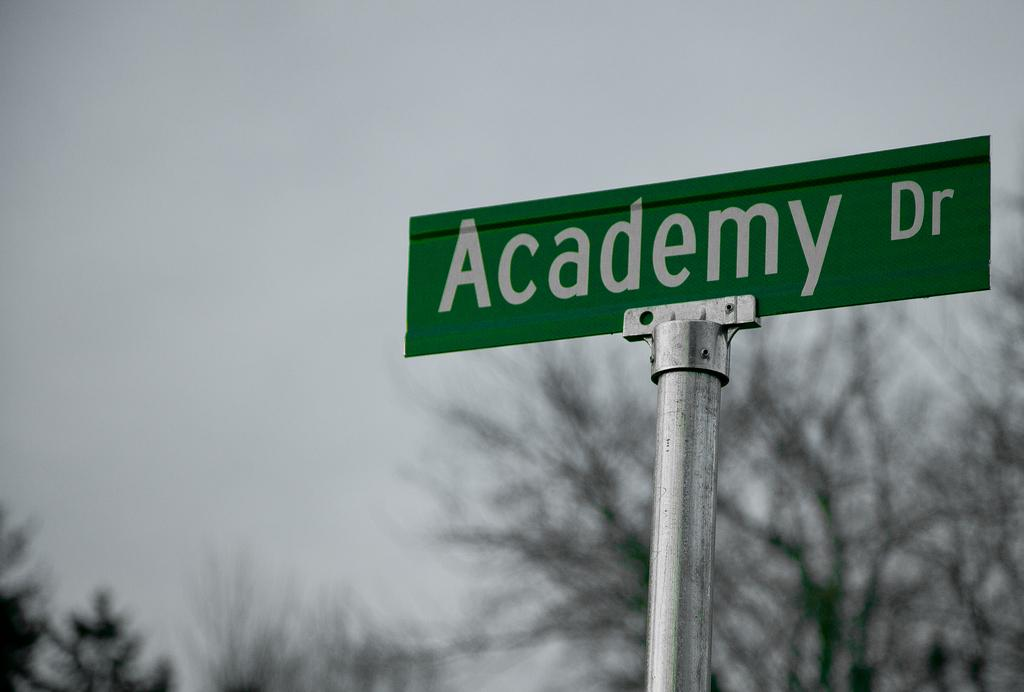What is the primary color of the board in the image? The primary color of the board in the image is green. What can be seen written on the board? There is a white color word on the board. How is the board positioned in the image? The board is fixed to a pole. What can be seen in the background of the image? Trees and the sky are visible in the background of the image. What news is being shared on the board in the image? There is no news being shared on the board in the image; it only contains a white color word. What belief is being promoted by the board in the image? There is no belief being promoted by the board in the image; it only contains a white color word. 